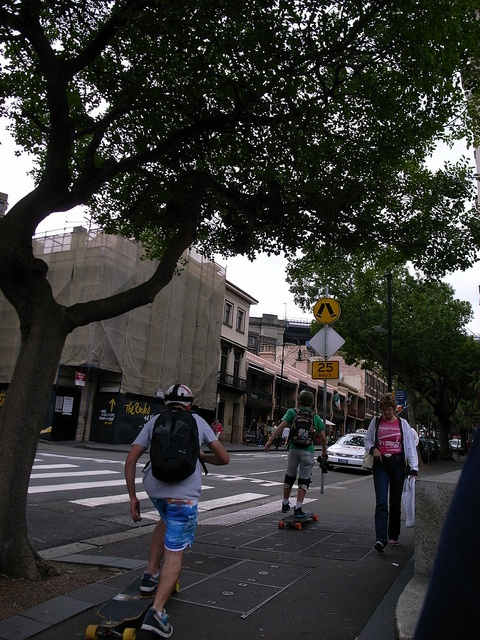Describe the objects in this image and their specific colors. I can see people in black, gray, navy, and maroon tones, people in black, gray, and maroon tones, people in black and gray tones, backpack in black and gray tones, and skateboard in black, olive, and gray tones in this image. 